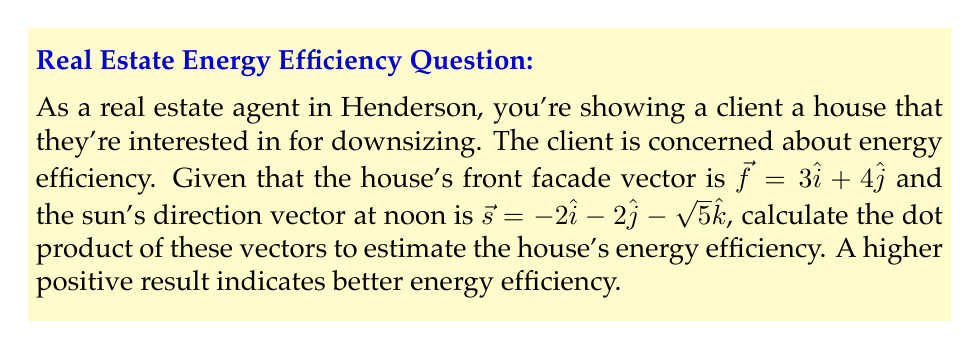What is the answer to this math problem? Let's approach this step-by-step:

1) We have two vectors:
   $\vec{f} = 3\hat{i} + 4\hat{j}$ (house front facade)
   $\vec{s} = -2\hat{i} - 2\hat{j} - \sqrt{5}\hat{k}$ (sun direction at noon)

2) The dot product of two vectors $\vec{a} = (a_1, a_2, a_3)$ and $\vec{b} = (b_1, b_2, b_3)$ is given by:
   $$\vec{a} \cdot \vec{b} = a_1b_1 + a_2b_2 + a_3b_3$$

3) In this case, we need to calculate:
   $$\vec{f} \cdot \vec{s} = (3)(-2) + (4)(-2) + (0)(-\sqrt{5})$$

4) Let's compute each term:
   $(3)(-2) = -6$
   $(4)(-2) = -8$
   $(0)(-\sqrt{5}) = 0$

5) Sum up the terms:
   $$\vec{f} \cdot \vec{s} = -6 + (-8) + 0 = -14$$

6) Interpret the result: The negative dot product indicates that the house's front facade is oriented away from the sun at noon, which is not ideal for energy efficiency.
Answer: $-14$ 